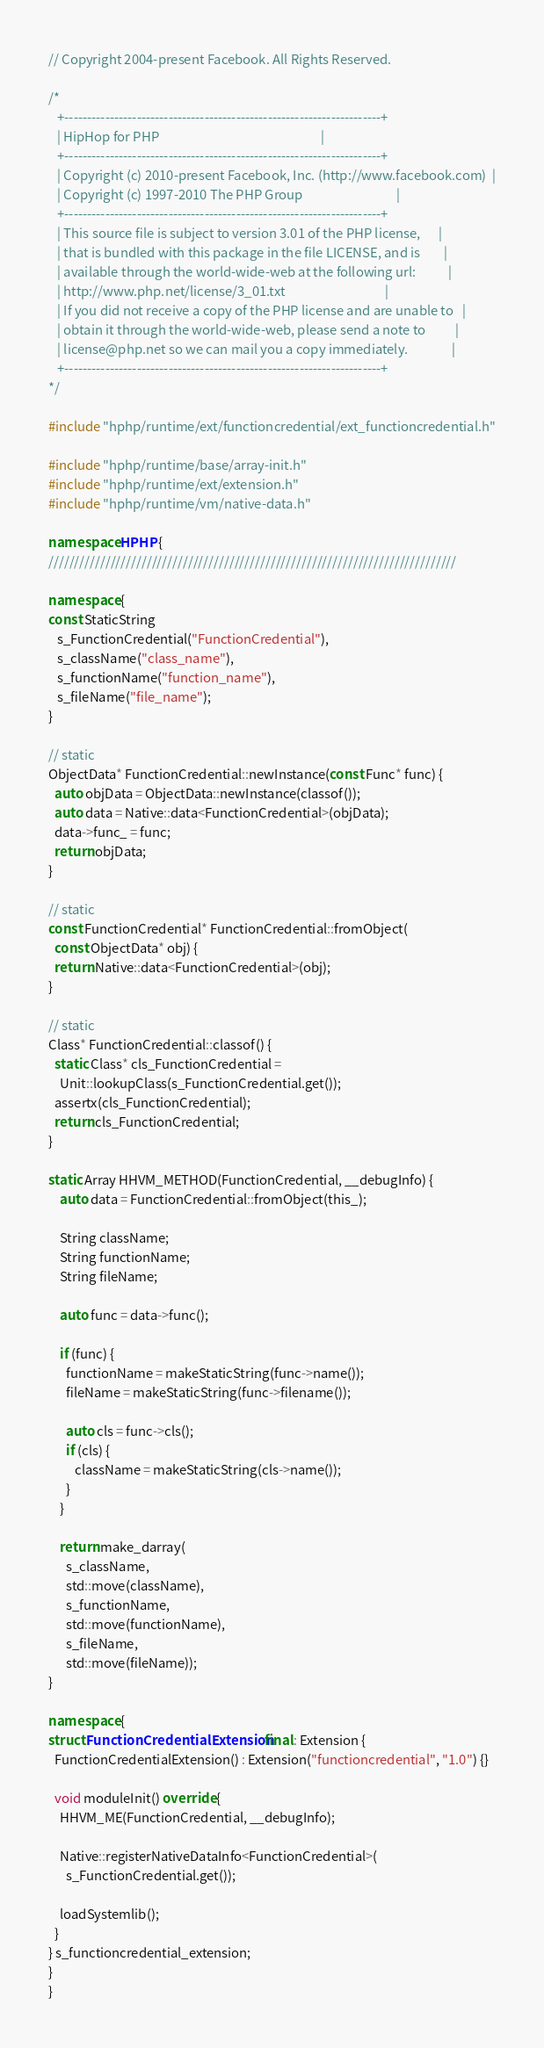Convert code to text. <code><loc_0><loc_0><loc_500><loc_500><_C++_>// Copyright 2004-present Facebook. All Rights Reserved.

/*
   +----------------------------------------------------------------------+
   | HipHop for PHP                                                       |
   +----------------------------------------------------------------------+
   | Copyright (c) 2010-present Facebook, Inc. (http://www.facebook.com)  |
   | Copyright (c) 1997-2010 The PHP Group                                |
   +----------------------------------------------------------------------+
   | This source file is subject to version 3.01 of the PHP license,      |
   | that is bundled with this package in the file LICENSE, and is        |
   | available through the world-wide-web at the following url:           |
   | http://www.php.net/license/3_01.txt                                  |
   | If you did not receive a copy of the PHP license and are unable to   |
   | obtain it through the world-wide-web, please send a note to          |
   | license@php.net so we can mail you a copy immediately.               |
   +----------------------------------------------------------------------+
*/

#include "hphp/runtime/ext/functioncredential/ext_functioncredential.h"

#include "hphp/runtime/base/array-init.h"
#include "hphp/runtime/ext/extension.h"
#include "hphp/runtime/vm/native-data.h"

namespace HPHP {
///////////////////////////////////////////////////////////////////////////////

namespace {
const StaticString
   s_FunctionCredential("FunctionCredential"),
   s_className("class_name"),
   s_functionName("function_name"),
   s_fileName("file_name");
}

// static
ObjectData* FunctionCredential::newInstance(const Func* func) {
  auto objData = ObjectData::newInstance(classof());
  auto data = Native::data<FunctionCredential>(objData);
  data->func_ = func;
  return objData;
}

// static
const FunctionCredential* FunctionCredential::fromObject(
  const ObjectData* obj) {
  return Native::data<FunctionCredential>(obj);
}

// static
Class* FunctionCredential::classof() {
  static Class* cls_FunctionCredential =
    Unit::lookupClass(s_FunctionCredential.get());
  assertx(cls_FunctionCredential);
  return cls_FunctionCredential;
}

static Array HHVM_METHOD(FunctionCredential, __debugInfo) {
    auto data = FunctionCredential::fromObject(this_);

    String className;
    String functionName;
    String fileName;

    auto func = data->func();

    if (func) {
      functionName = makeStaticString(func->name());
      fileName = makeStaticString(func->filename());

      auto cls = func->cls();
      if (cls) {
         className = makeStaticString(cls->name());
      }
    }

    return make_darray(
      s_className,
      std::move(className),
      s_functionName,
      std::move(functionName),
      s_fileName,
      std::move(fileName));
}

namespace {
struct FunctionCredentialExtension final : Extension {
  FunctionCredentialExtension() : Extension("functioncredential", "1.0") {}

  void moduleInit() override {
    HHVM_ME(FunctionCredential, __debugInfo);

    Native::registerNativeDataInfo<FunctionCredential>(
      s_FunctionCredential.get());

    loadSystemlib();
  }
} s_functioncredential_extension;
}
}
</code> 